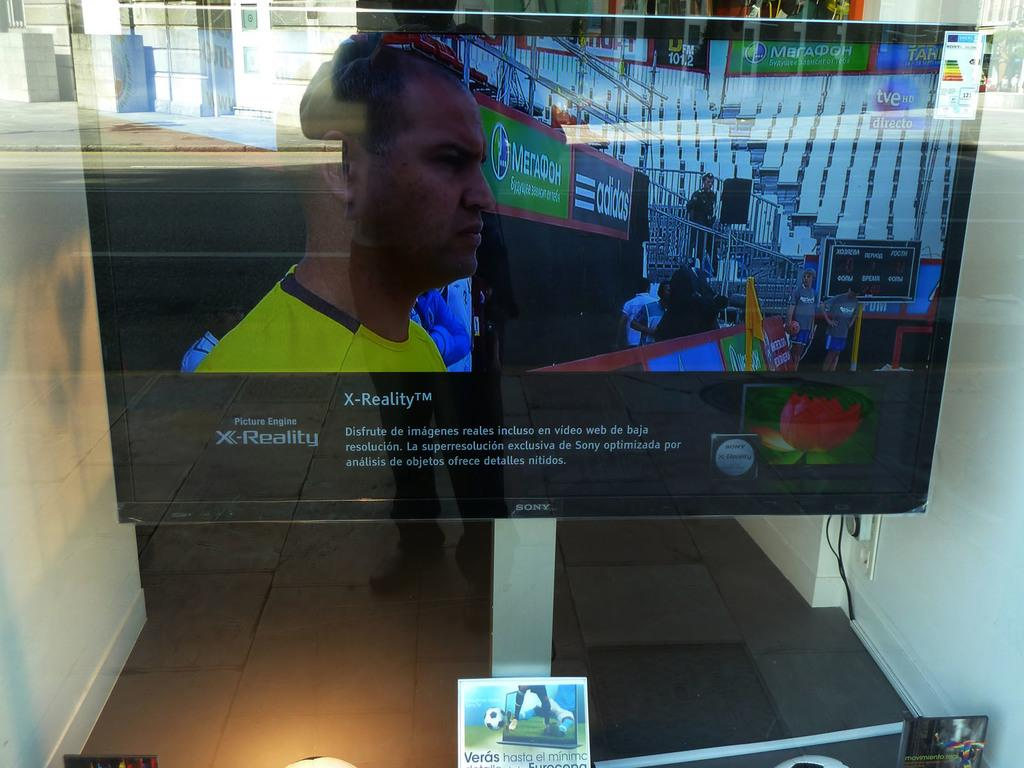<image>
Describe the image concisely. A large screen which is made by  the company Sony. 